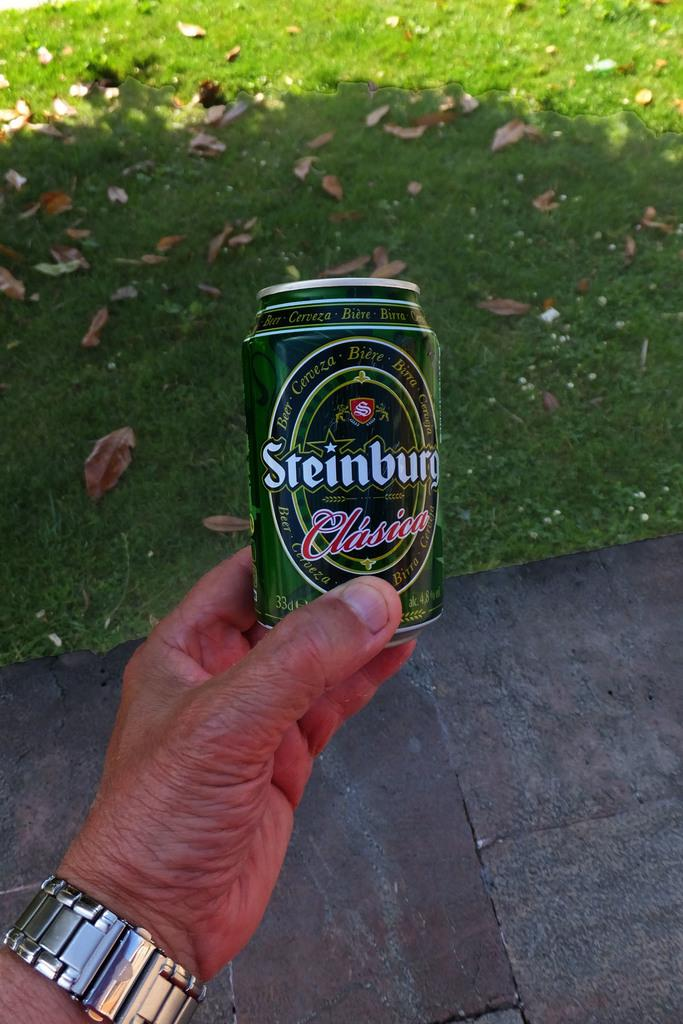<image>
Summarize the visual content of the image. A man is holding a can of Steinburg beer in his hand. 